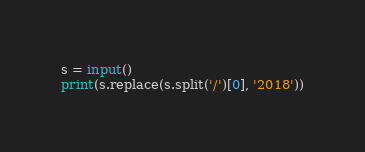Convert code to text. <code><loc_0><loc_0><loc_500><loc_500><_Python_>s = input()
print(s.replace(s.split('/')[0], '2018'))</code> 